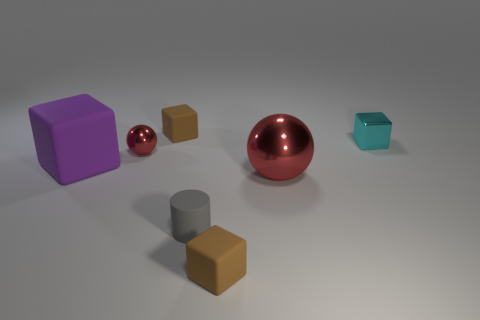Add 1 big red balls. How many objects exist? 8 Subtract all cylinders. How many objects are left? 6 Subtract 0 green cubes. How many objects are left? 7 Subtract all red metallic objects. Subtract all small gray matte cylinders. How many objects are left? 4 Add 1 small brown matte cubes. How many small brown matte cubes are left? 3 Add 7 large yellow metallic cylinders. How many large yellow metallic cylinders exist? 7 